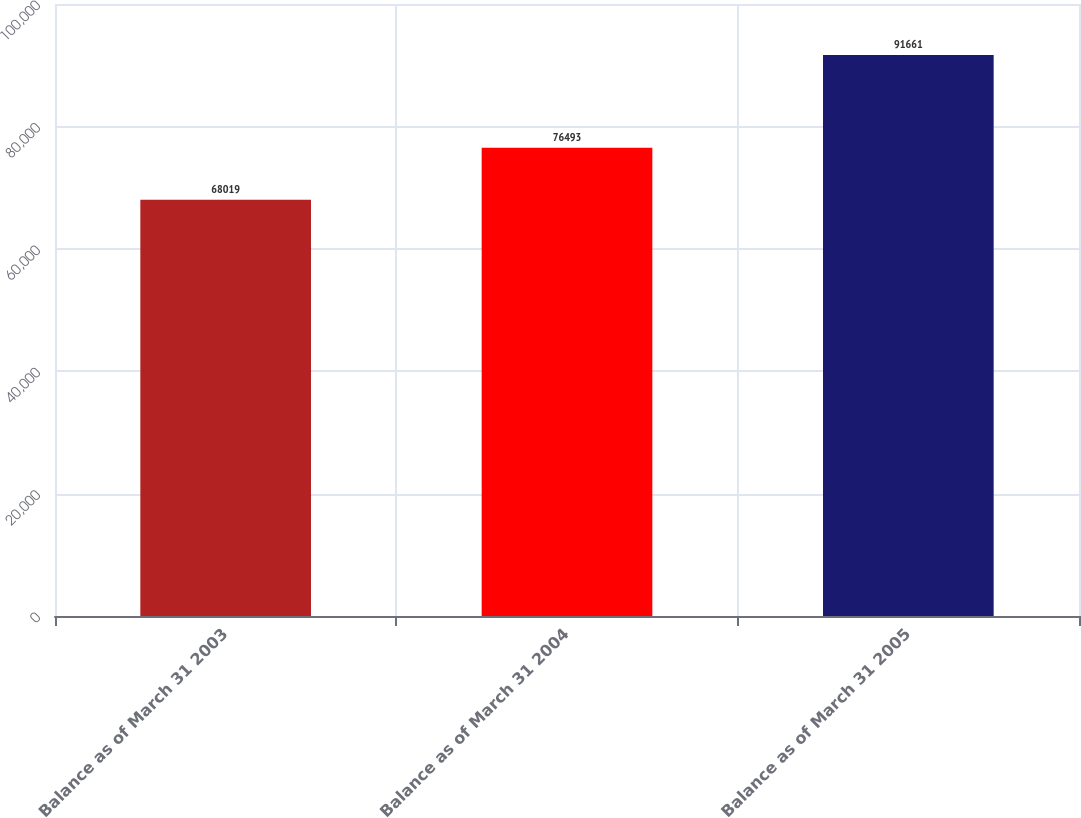Convert chart. <chart><loc_0><loc_0><loc_500><loc_500><bar_chart><fcel>Balance as of March 31 2003<fcel>Balance as of March 31 2004<fcel>Balance as of March 31 2005<nl><fcel>68019<fcel>76493<fcel>91661<nl></chart> 